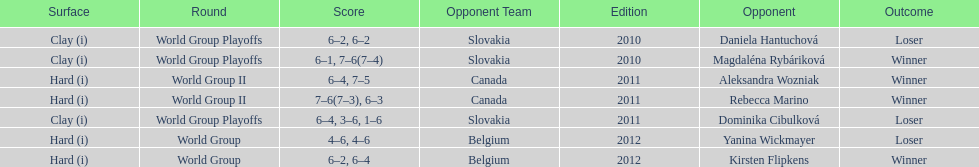Was the match against canada after the match against belgium? No. 